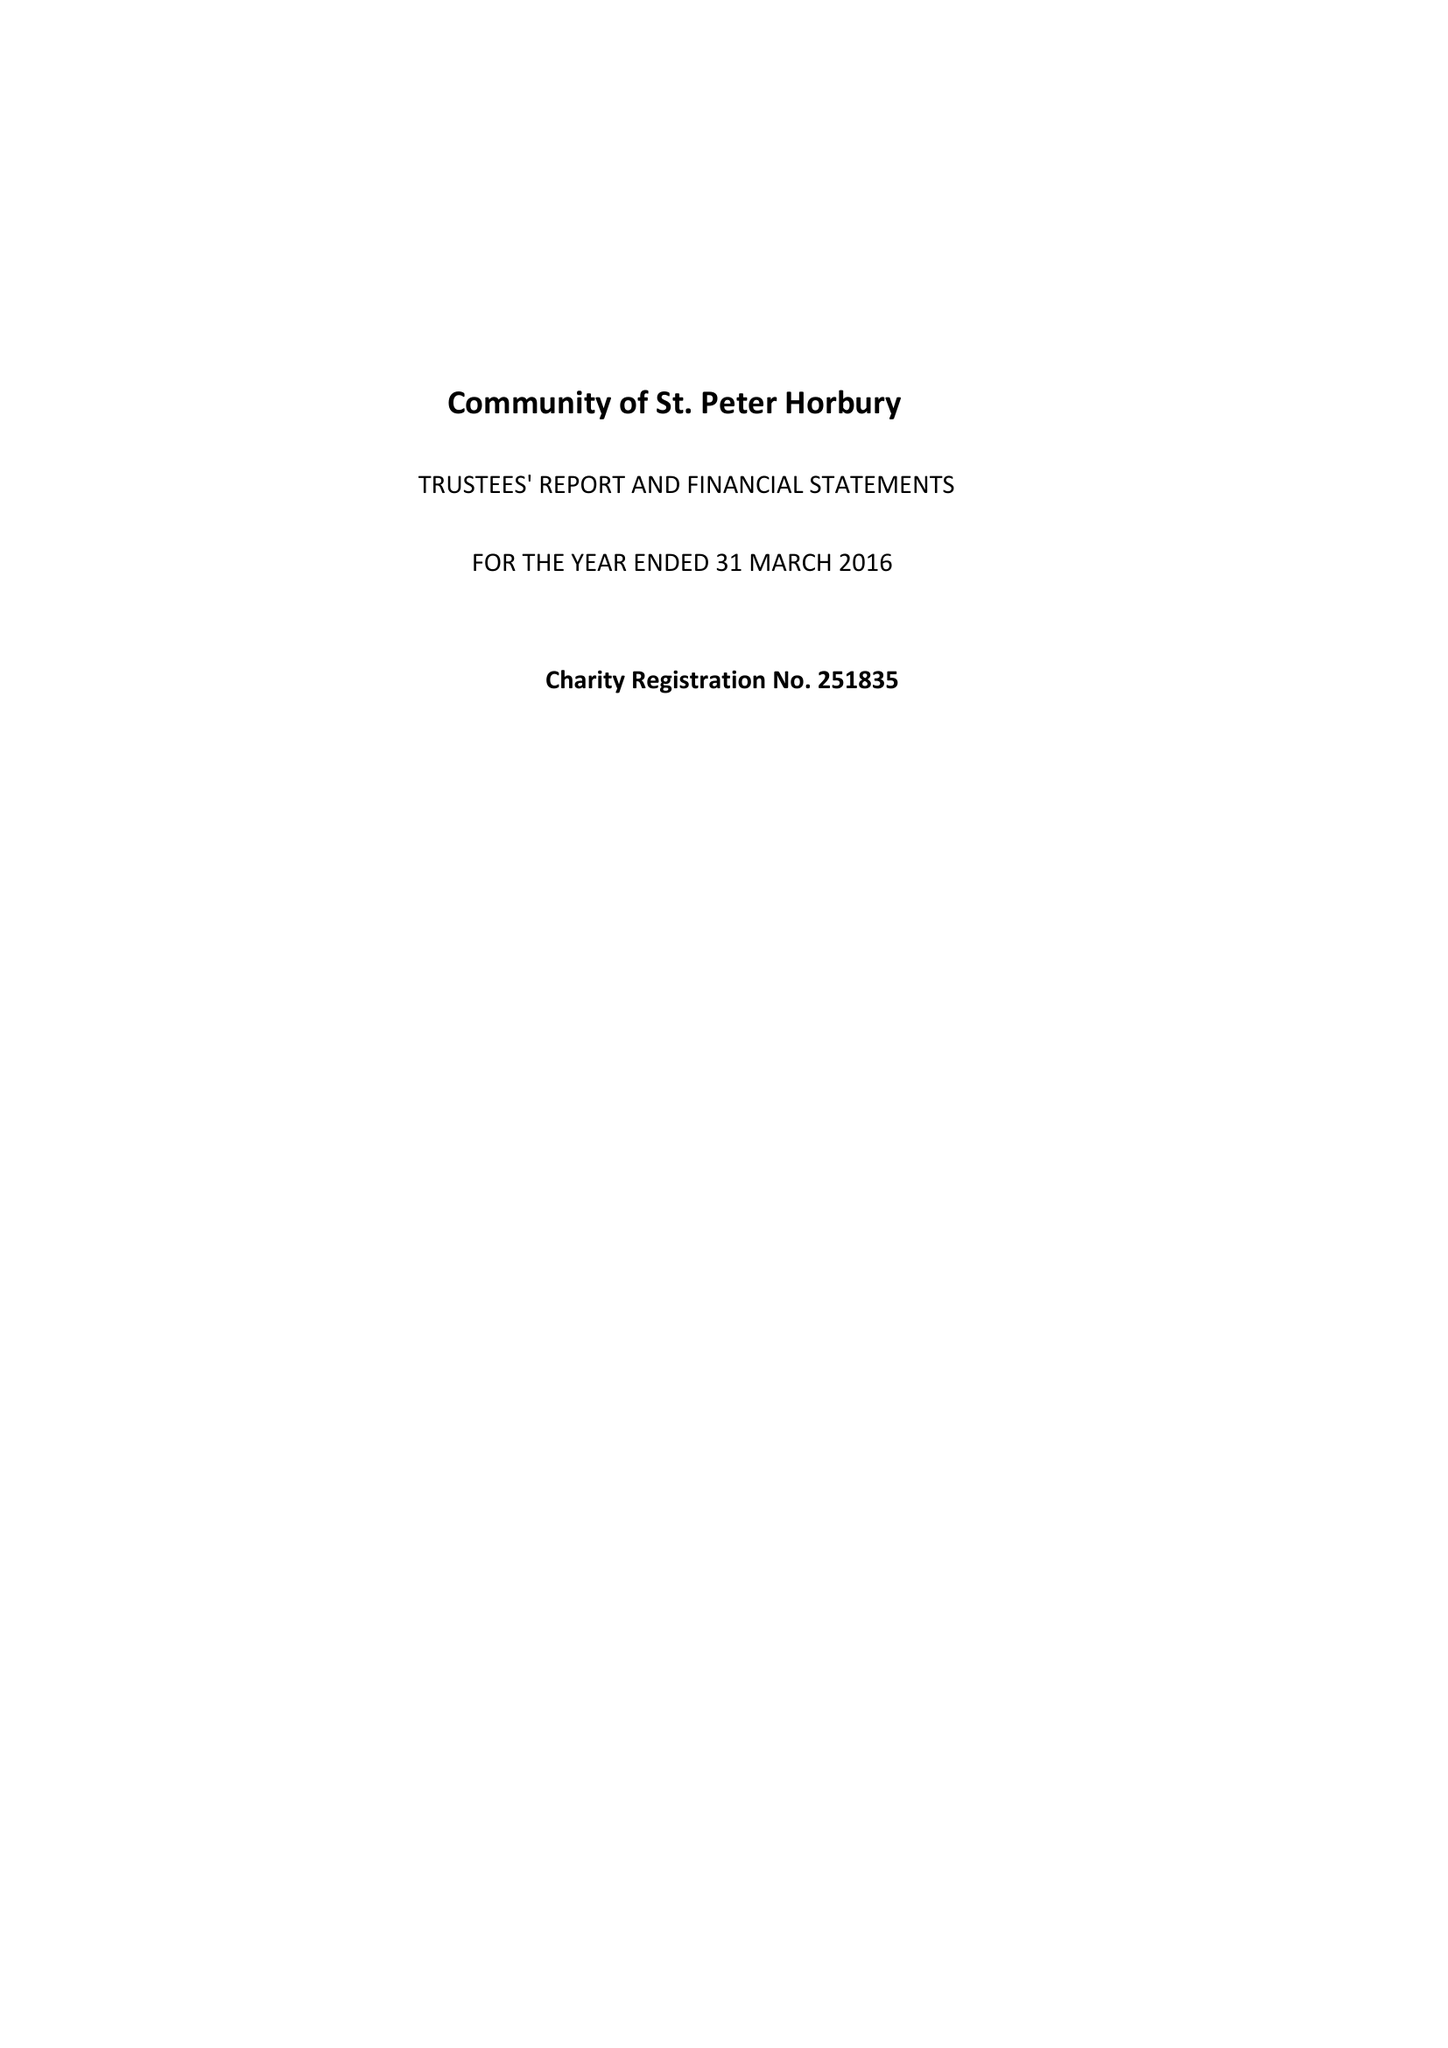What is the value for the spending_annually_in_british_pounds?
Answer the question using a single word or phrase. 178063.00 